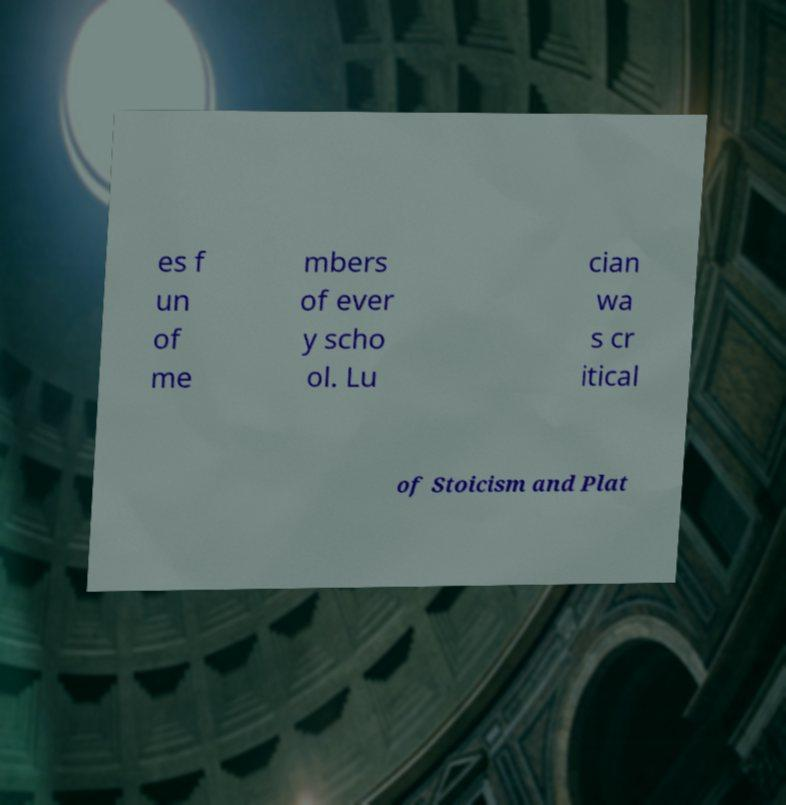What messages or text are displayed in this image? I need them in a readable, typed format. es f un of me mbers of ever y scho ol. Lu cian wa s cr itical of Stoicism and Plat 